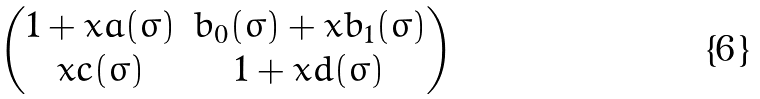<formula> <loc_0><loc_0><loc_500><loc_500>\begin{pmatrix} 1 + x a ( \sigma ) & b _ { 0 } ( \sigma ) + x b _ { 1 } ( \sigma ) \\ x c ( \sigma ) & 1 + x d ( \sigma ) \end{pmatrix}</formula> 